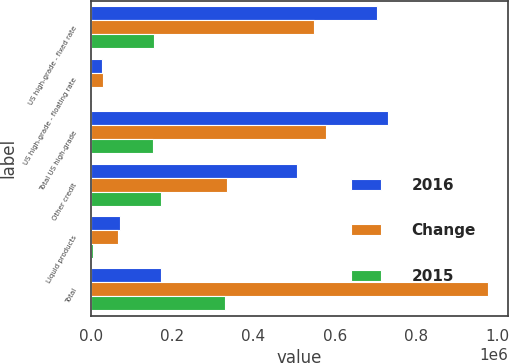Convert chart. <chart><loc_0><loc_0><loc_500><loc_500><stacked_bar_chart><ecel><fcel>US high-grade - fixed rate<fcel>US high-grade - floating rate<fcel>Total US high-grade<fcel>Other credit<fcel>Liquid products<fcel>Total<nl><fcel>2016<fcel>704648<fcel>25917<fcel>730565<fcel>506762<fcel>71375<fcel>171249<nl><fcel>Change<fcel>549086<fcel>28547<fcel>577633<fcel>335513<fcel>65365<fcel>978511<nl><fcel>2015<fcel>155562<fcel>2630<fcel>152932<fcel>171249<fcel>6010<fcel>330191<nl></chart> 